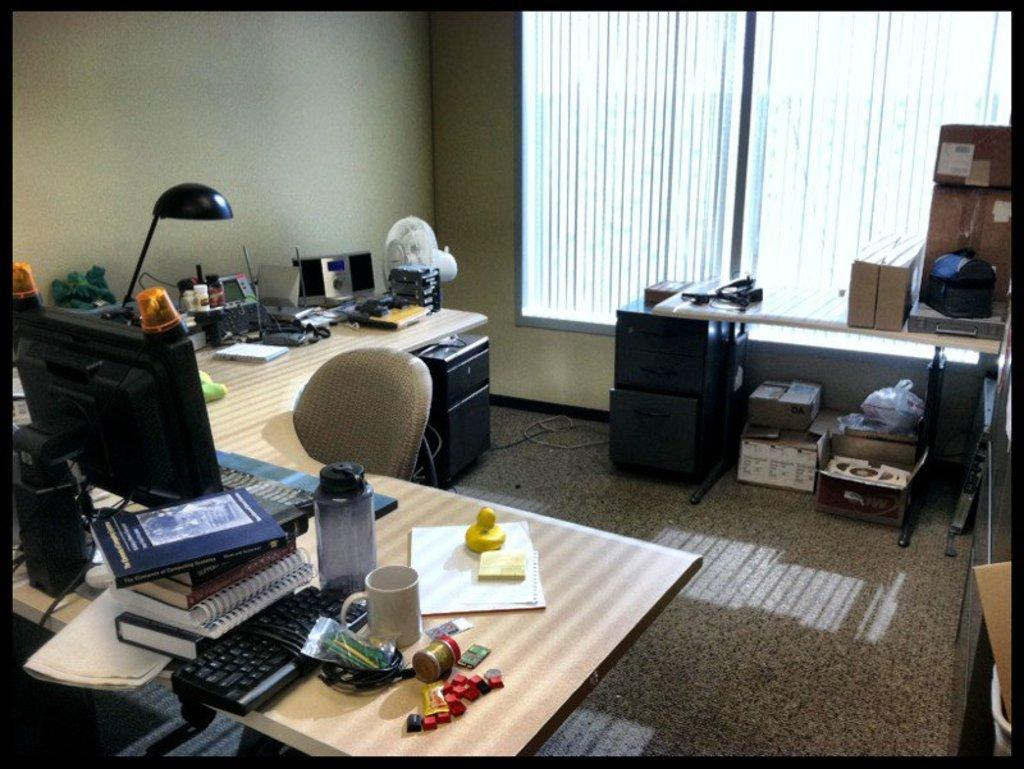What type of furniture is present in the image? There is a desktop, a chair, and a table in the image. What is on top of the table in the image? There are boxes on the table in the image. What type of police toad beast can be seen in the image? There is no police toad beast present in the image; the image only contains a desktop, chair, table, and boxes. 